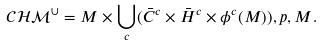<formula> <loc_0><loc_0><loc_500><loc_500>\mathcal { C H M } ^ { \cup } = M \times \bigcup _ { c } ( \bar { C } ^ { c } \times \bar { H } ^ { c } \times \phi ^ { c } ( M ) ) , p , M .</formula> 